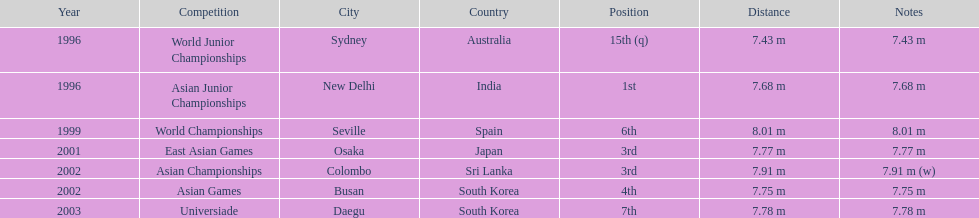Which competition did this person compete in immediately before the east asian games in 2001? World Championships. 